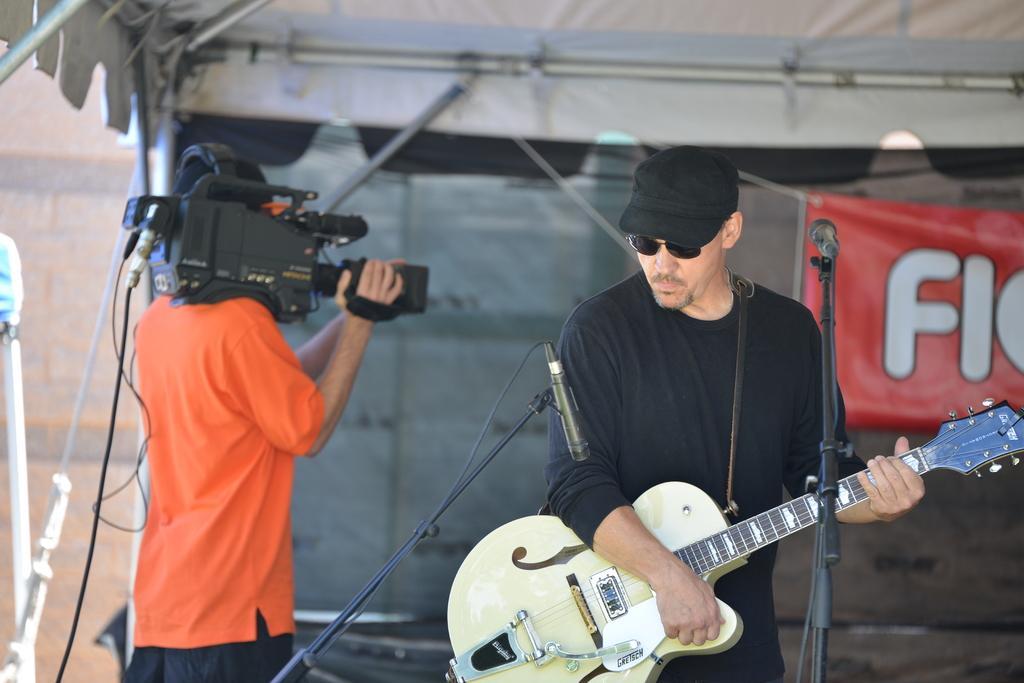In one or two sentences, can you explain what this image depicts? In this image, There is a man standing at the right side holding a music instrument and there are microphones which are in black color, There is a man holding a camera at the left side, and in the background there is a wall and a poster in red color,and in the top there is a white color roof. 